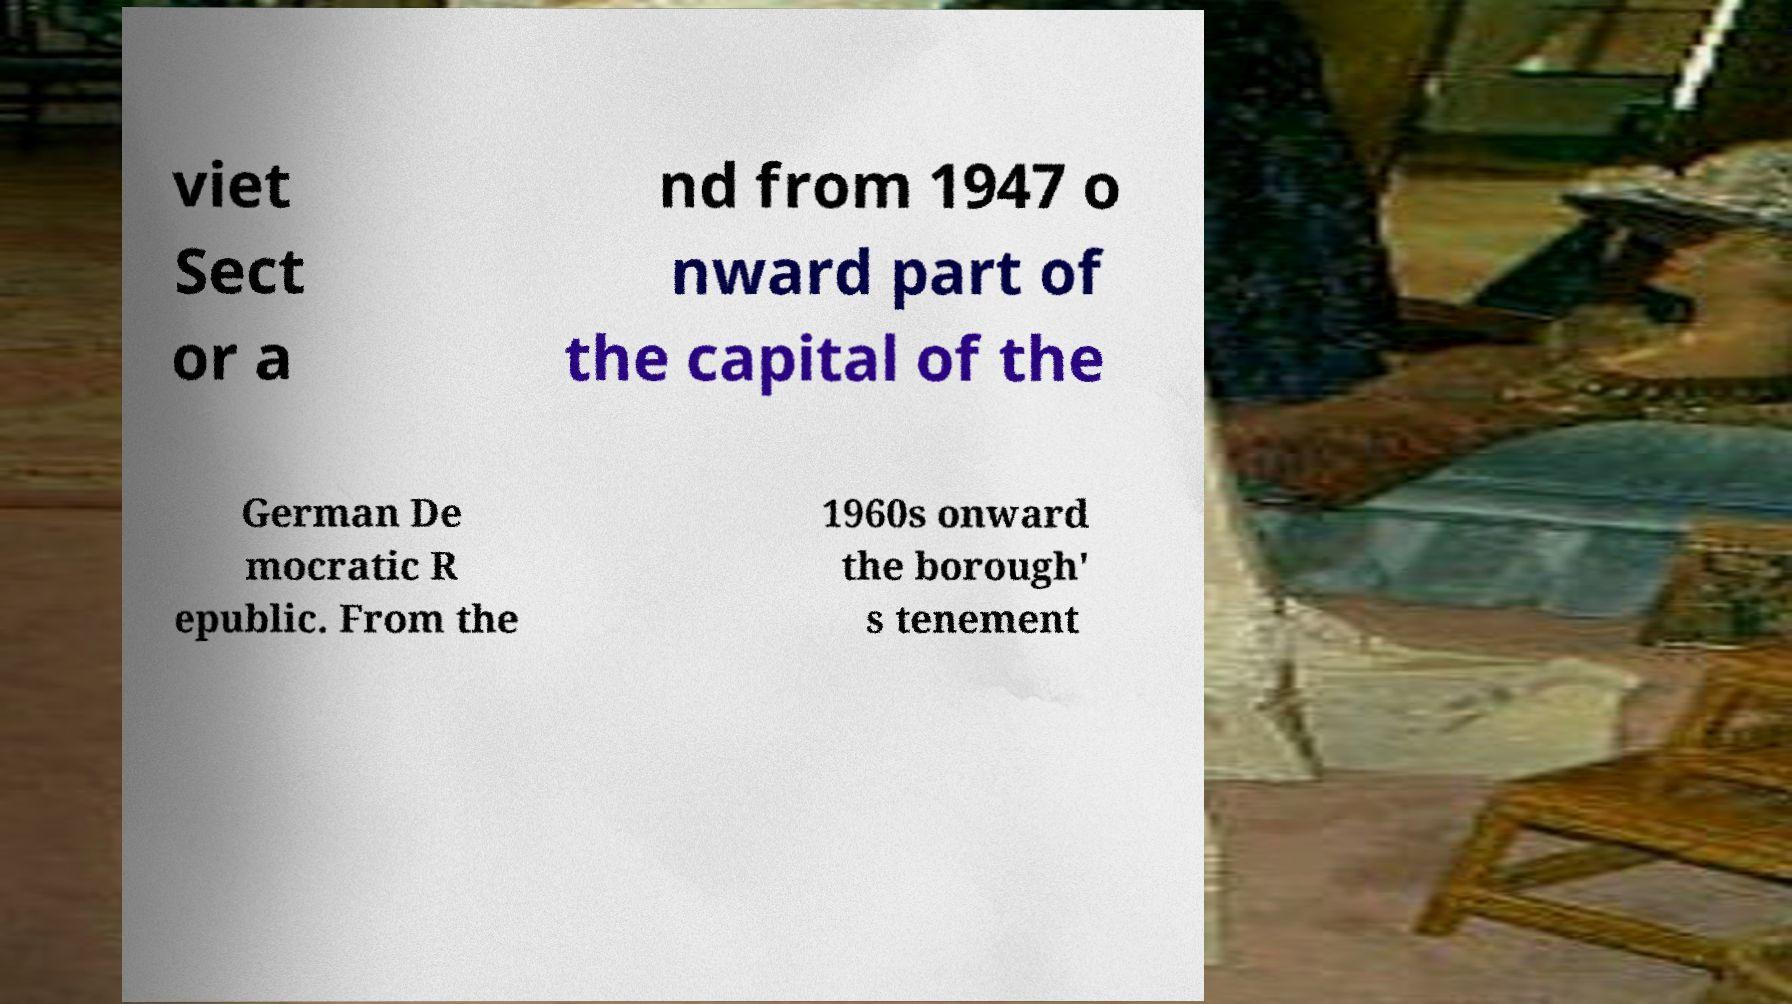Please identify and transcribe the text found in this image. viet Sect or a nd from 1947 o nward part of the capital of the German De mocratic R epublic. From the 1960s onward the borough' s tenement 